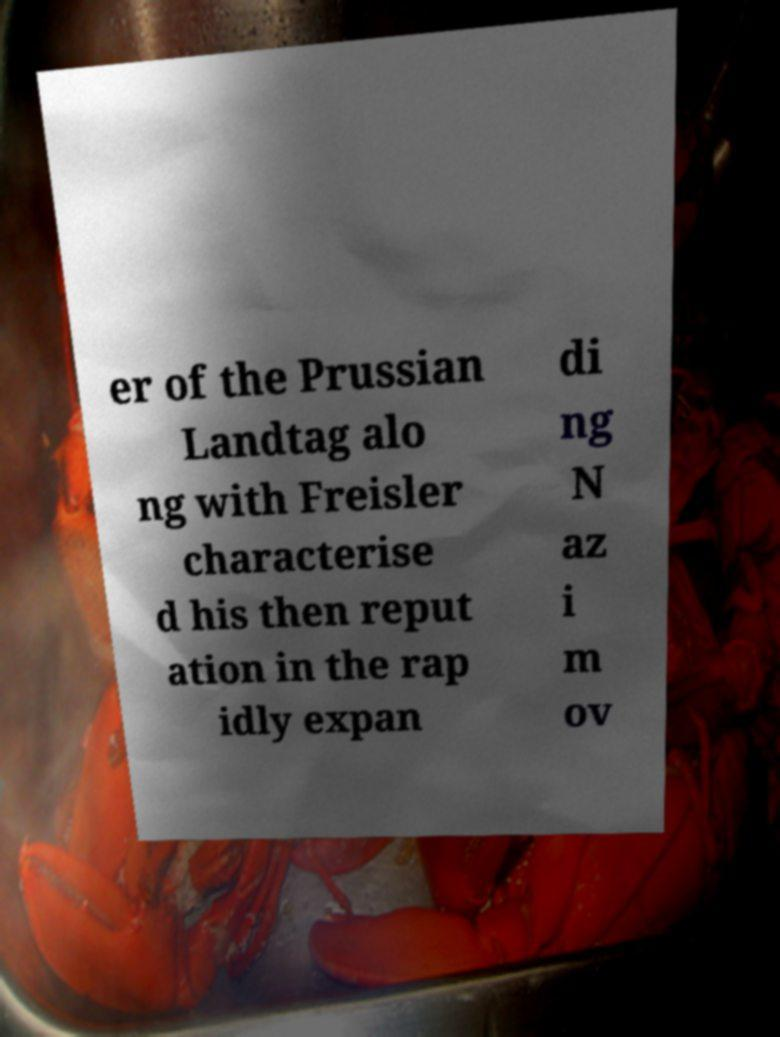What messages or text are displayed in this image? I need them in a readable, typed format. er of the Prussian Landtag alo ng with Freisler characterise d his then reput ation in the rap idly expan di ng N az i m ov 